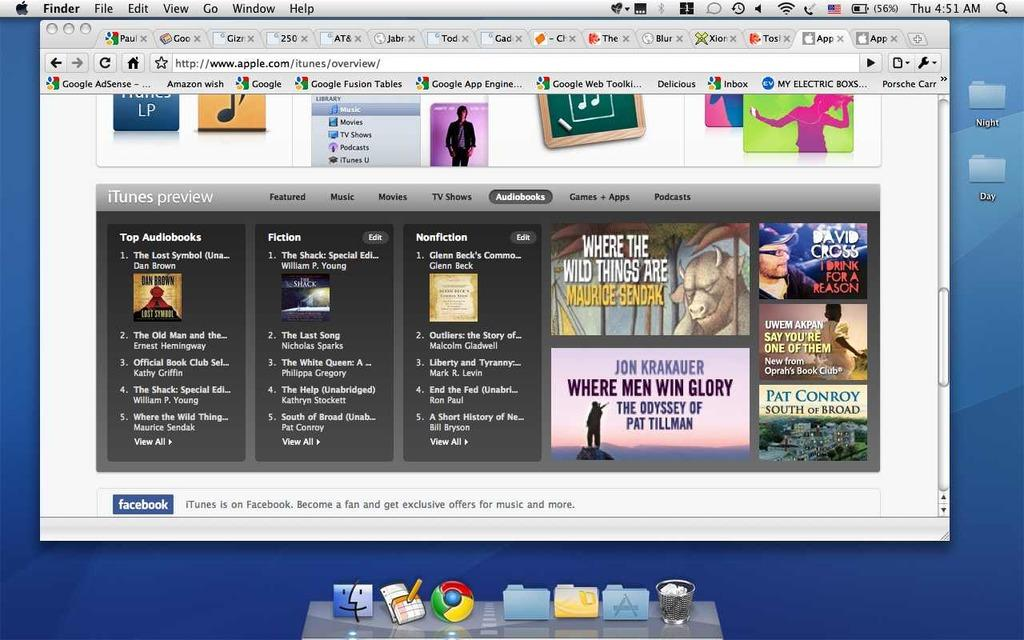<image>
Give a short and clear explanation of the subsequent image. a picture of a screenshot of a mac screen with a window open. 